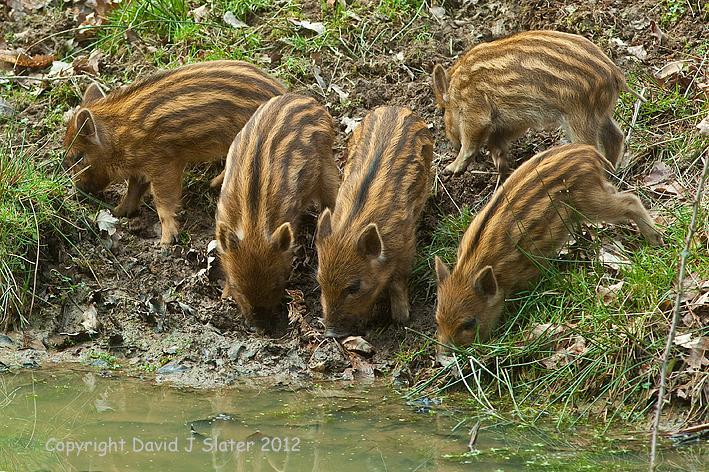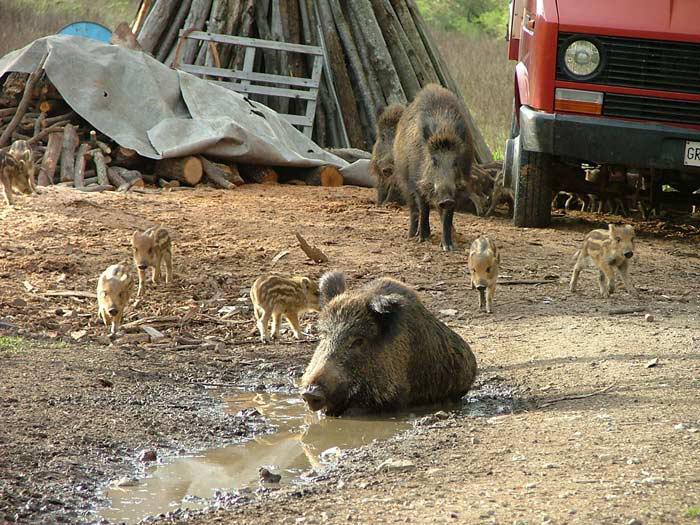The first image is the image on the left, the second image is the image on the right. Given the left and right images, does the statement "Piglets are standing beside an adult pig in both images." hold true? Answer yes or no. No. 